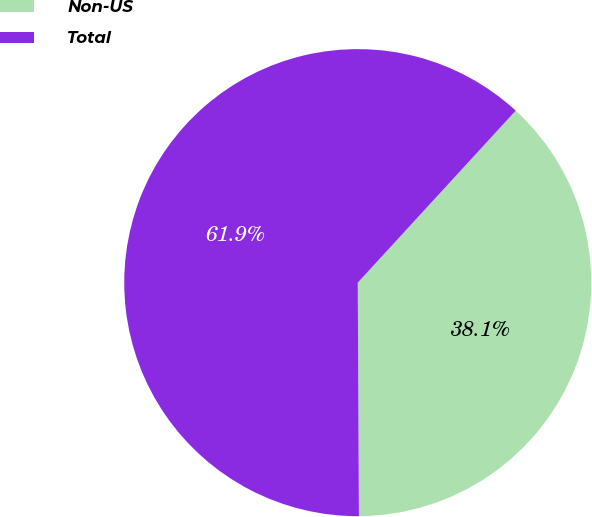<chart> <loc_0><loc_0><loc_500><loc_500><pie_chart><fcel>Non-US<fcel>Total<nl><fcel>38.1%<fcel>61.9%<nl></chart> 